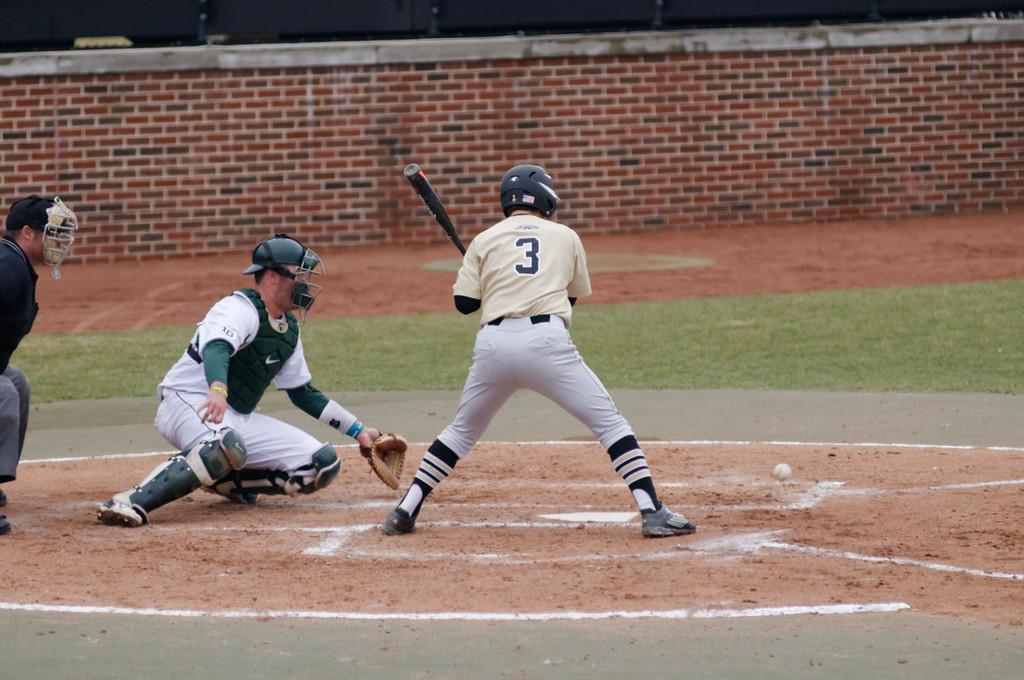<image>
Give a short and clear explanation of the subsequent image. A baseball player with a bat and the number 3 on his shirt. 